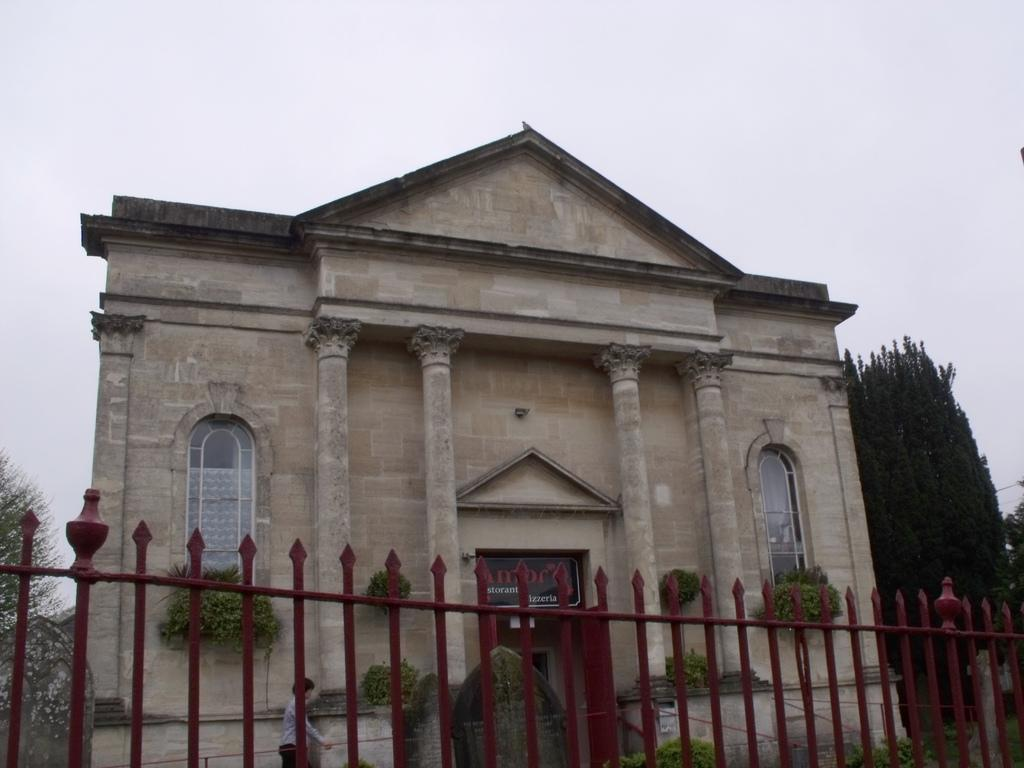What type of structure is present in the image? There is a building in the image. What other objects can be seen inside the building? There are house plants and persons on the floor in the image. What architectural feature is present in the image? There is an iron grill in the image. What type of vegetation is visible in the image? There are trees in the image. What part of the natural environment is visible in the image? The sky is visible in the image. What type of doll is placed on the cemetery in the image? There is no cemetery or doll present in the image. What is the doll doing in the image? There is no doll present in the image, so it cannot be determined what it might be doing. 